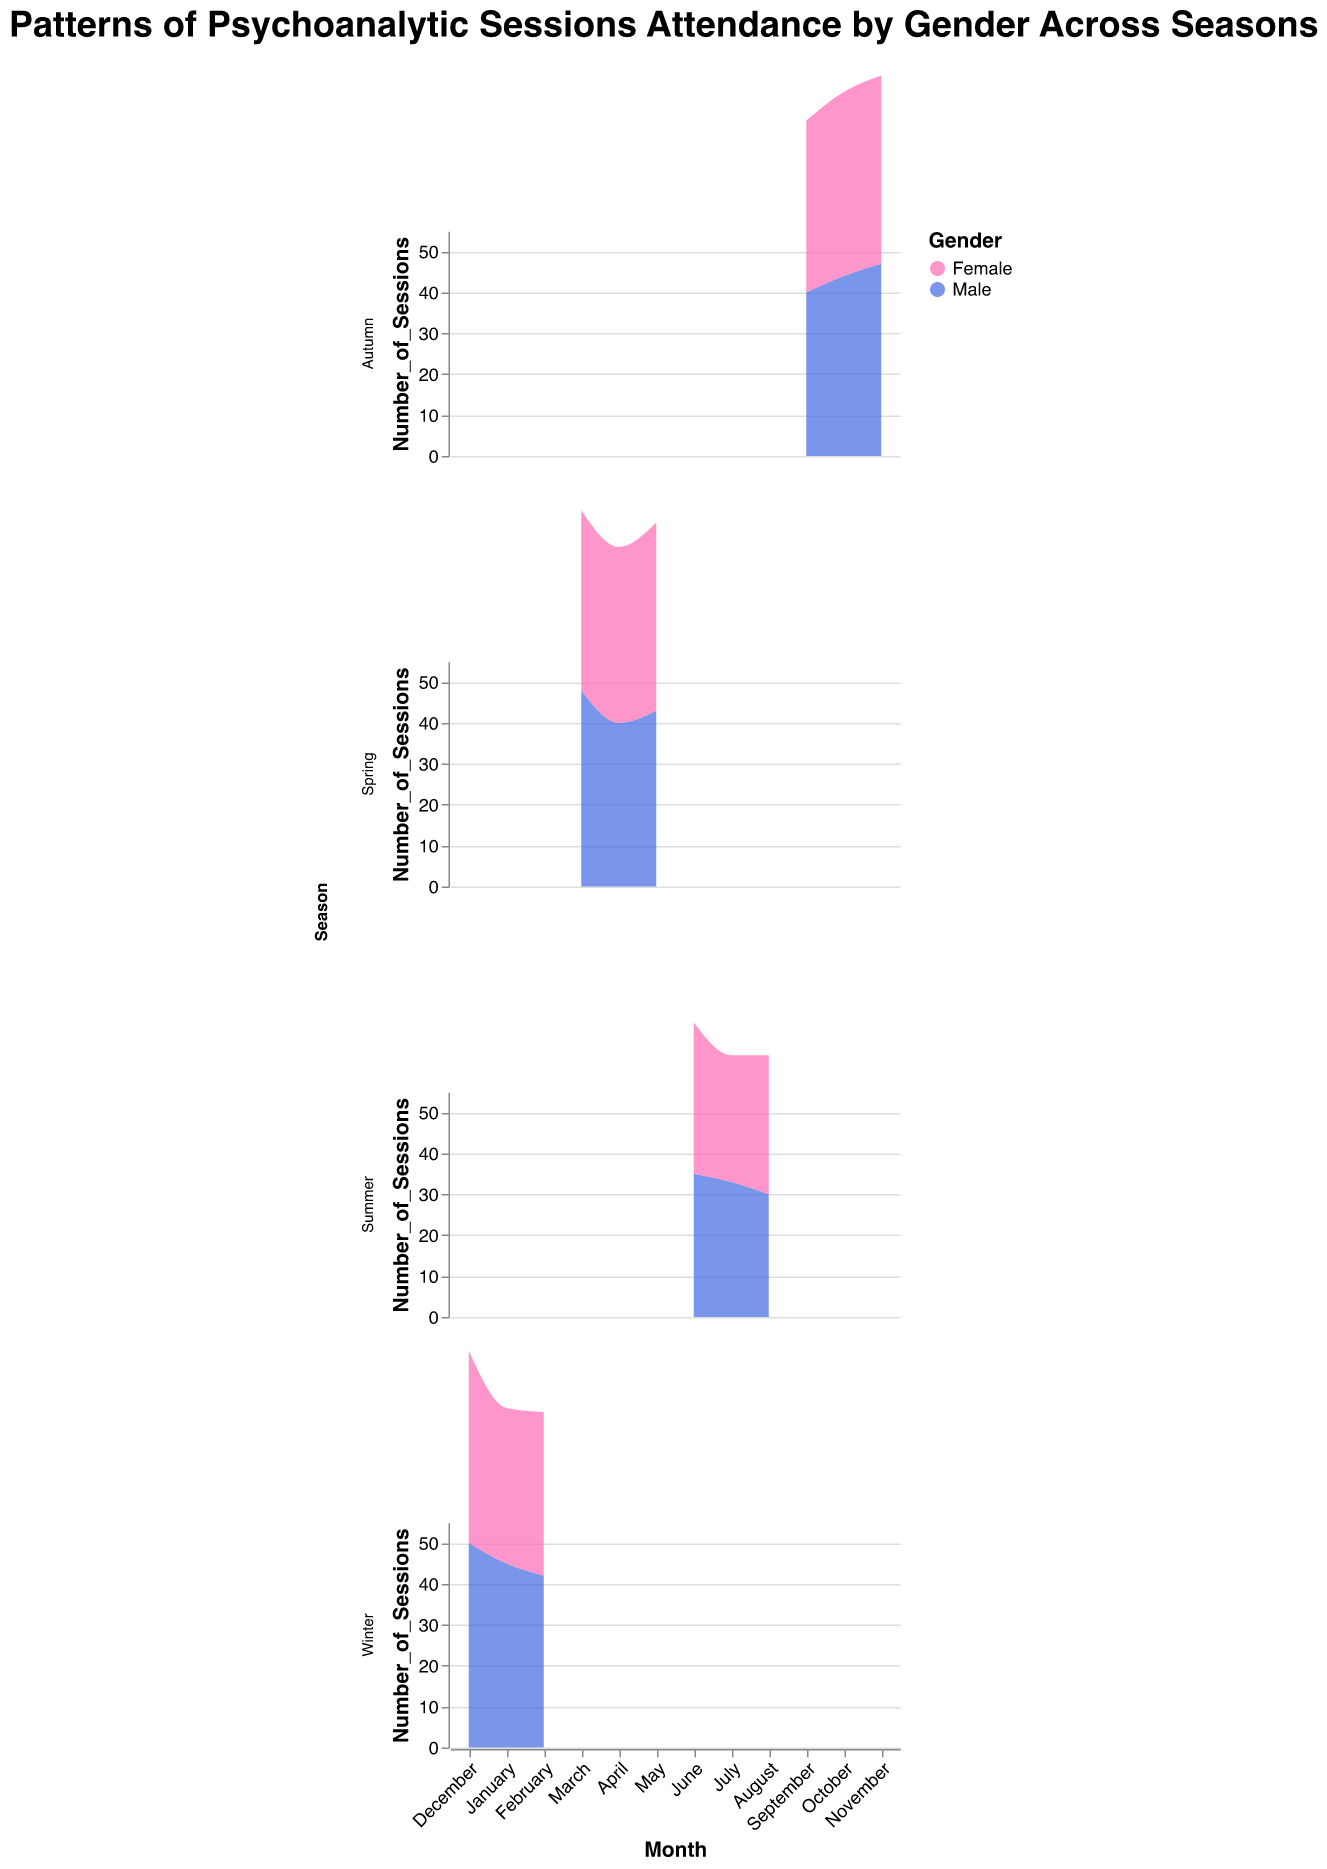What is the title of the figure? The title is typically found at the top of the figure and describes what the figure represents.
Answer: Patterns of Psychoanalytic Sessions Attendance by Gender Across Seasons What months are displayed on the x-axis? The x-axis labels can be seen beneath each subplot.
Answer: December, January, February, March, April, May, June, July, August, September, October, November In which season do males attend the most sessions? Look at the height of the area chart for males in each season and identify the season with the highest peak.
Answer: Winter Which season shows the smallest difference in session attendance between genders? Compare the differences in the height of the areas for each gender within each season and find which one has the smallest difference.
Answer: Autumn What is the month with the lowest number of sessions attended by males? Check the height of the male area chart to find the month with the shortest height.
Answer: August Which gender generally has higher attendance across the year? Observe the general trend by comparing the heights of the female and male areas throughout the entire figure.
Answer: Male Calculate the average number of sessions attended by females in Winter. Add the number of female sessions in December, January, and February, then divide by three. (47 + 38 + 40) / 3 = 125 / 3
Answer: 41.67 During which month does the attendance for both genders equally high? Look for the month(s) where the peaks of both gender areas are at the same height or very close.
Answer: February Does the attendance pattern of males vary more than that of females between seasons? Compare the differences in heights of the male area and female area across all seasons to see which has more variability.
Answer: Yes, males show more variability In which month do females attend more sessions than males? Compare each month's attendance by looking at the height of the female area versus the male area.
Answer: April 